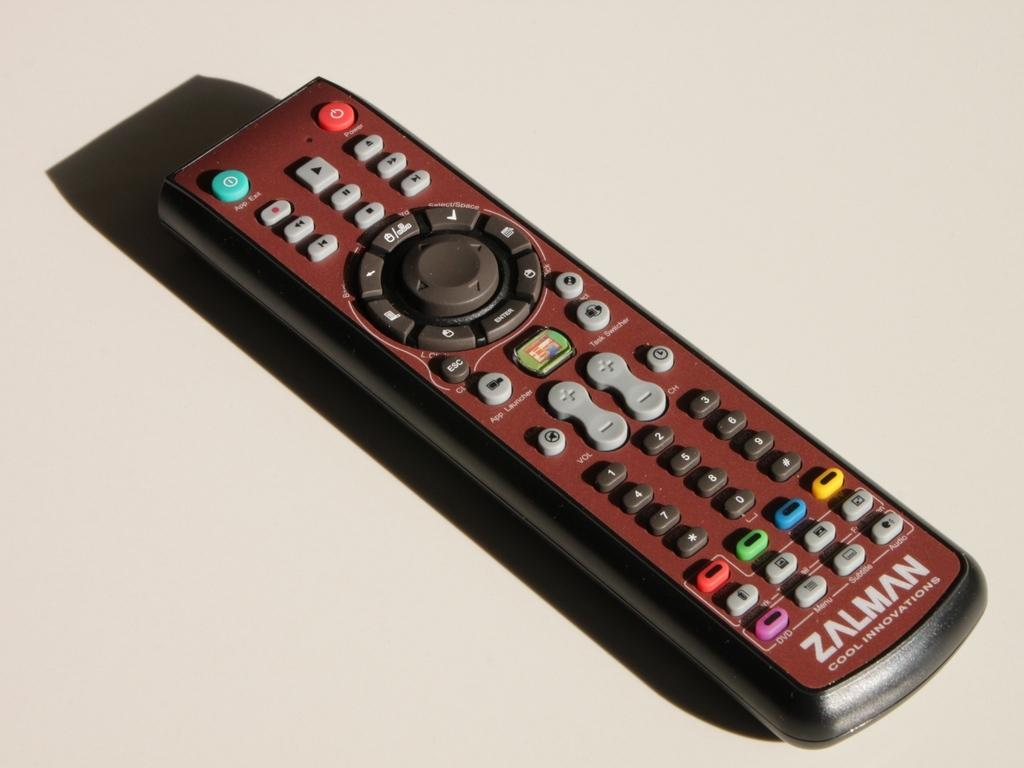<image>
Describe the image concisely. A red and black Zalman TV remote on a white surface. 